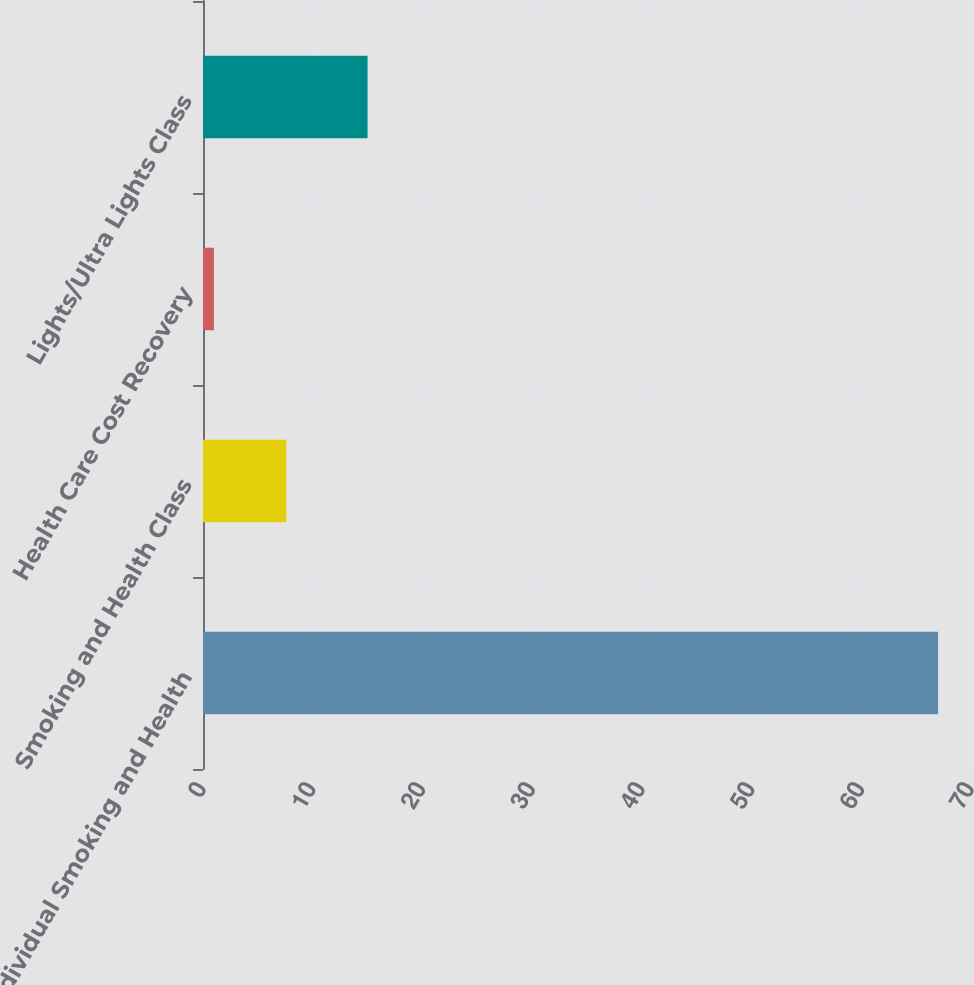<chart> <loc_0><loc_0><loc_500><loc_500><bar_chart><fcel>Individual Smoking and Health<fcel>Smoking and Health Class<fcel>Health Care Cost Recovery<fcel>Lights/Ultra Lights Class<nl><fcel>67<fcel>7.6<fcel>1<fcel>15<nl></chart> 